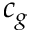<formula> <loc_0><loc_0><loc_500><loc_500>c _ { g }</formula> 